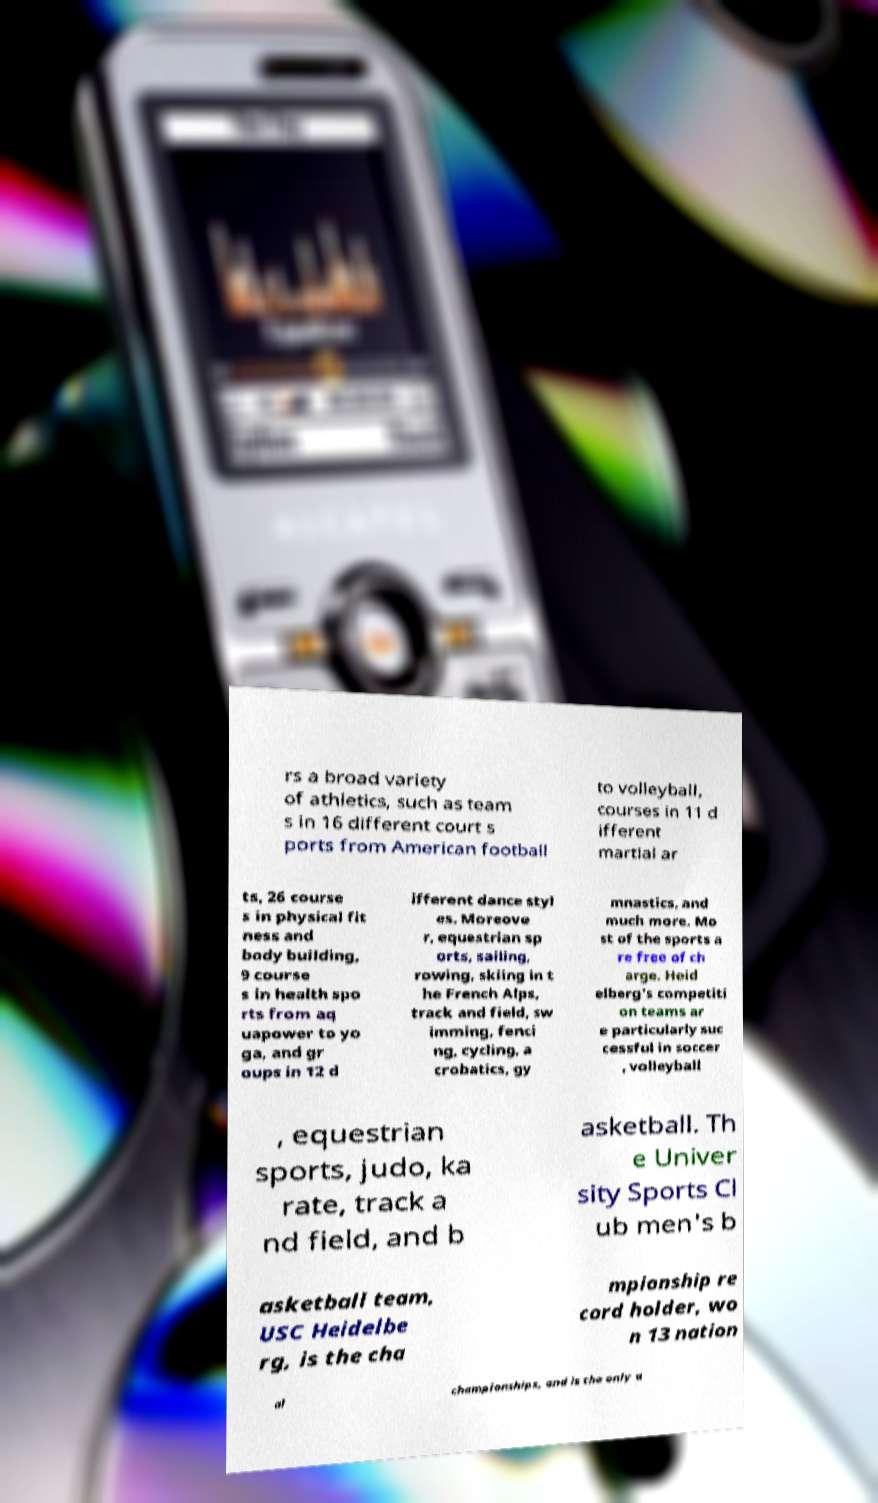Please read and relay the text visible in this image. What does it say? rs a broad variety of athletics, such as team s in 16 different court s ports from American football to volleyball, courses in 11 d ifferent martial ar ts, 26 course s in physical fit ness and body building, 9 course s in health spo rts from aq uapower to yo ga, and gr oups in 12 d ifferent dance styl es. Moreove r, equestrian sp orts, sailing, rowing, skiing in t he French Alps, track and field, sw imming, fenci ng, cycling, a crobatics, gy mnastics, and much more. Mo st of the sports a re free of ch arge. Heid elberg's competiti on teams ar e particularly suc cessful in soccer , volleyball , equestrian sports, judo, ka rate, track a nd field, and b asketball. Th e Univer sity Sports Cl ub men's b asketball team, USC Heidelbe rg, is the cha mpionship re cord holder, wo n 13 nation al championships, and is the only u 